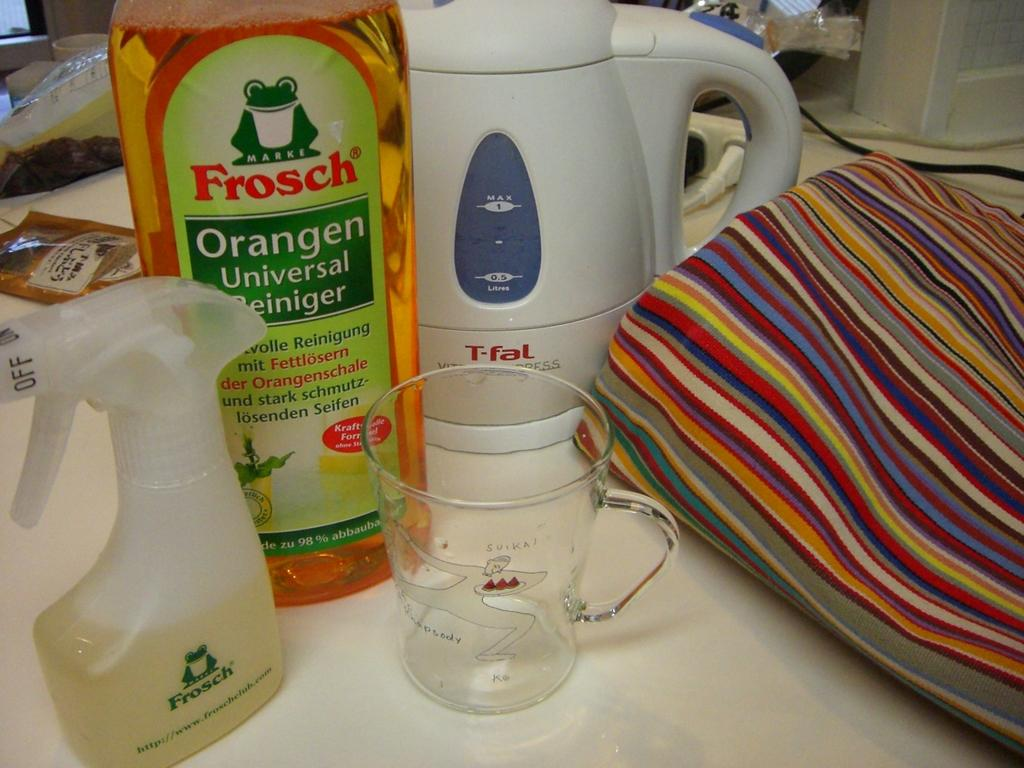<image>
Present a compact description of the photo's key features. Among many things on a counter is a spray bottled that is branded Frosch. 